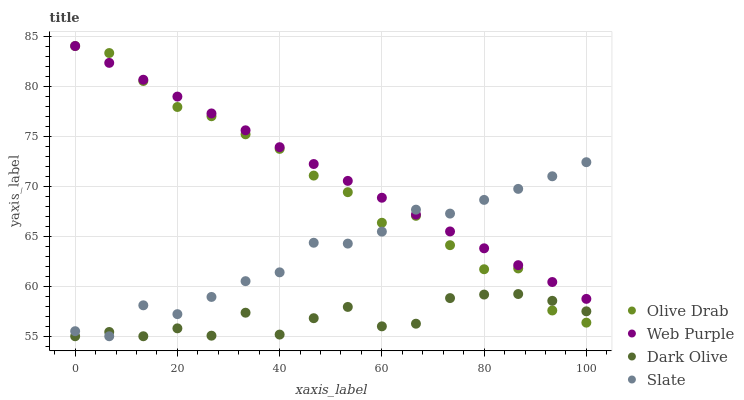Does Dark Olive have the minimum area under the curve?
Answer yes or no. Yes. Does Web Purple have the maximum area under the curve?
Answer yes or no. Yes. Does Slate have the minimum area under the curve?
Answer yes or no. No. Does Slate have the maximum area under the curve?
Answer yes or no. No. Is Web Purple the smoothest?
Answer yes or no. Yes. Is Dark Olive the roughest?
Answer yes or no. Yes. Is Slate the smoothest?
Answer yes or no. No. Is Slate the roughest?
Answer yes or no. No. Does Dark Olive have the lowest value?
Answer yes or no. Yes. Does Olive Drab have the lowest value?
Answer yes or no. No. Does Olive Drab have the highest value?
Answer yes or no. Yes. Does Slate have the highest value?
Answer yes or no. No. Is Dark Olive less than Web Purple?
Answer yes or no. Yes. Is Web Purple greater than Dark Olive?
Answer yes or no. Yes. Does Olive Drab intersect Dark Olive?
Answer yes or no. Yes. Is Olive Drab less than Dark Olive?
Answer yes or no. No. Is Olive Drab greater than Dark Olive?
Answer yes or no. No. Does Dark Olive intersect Web Purple?
Answer yes or no. No. 